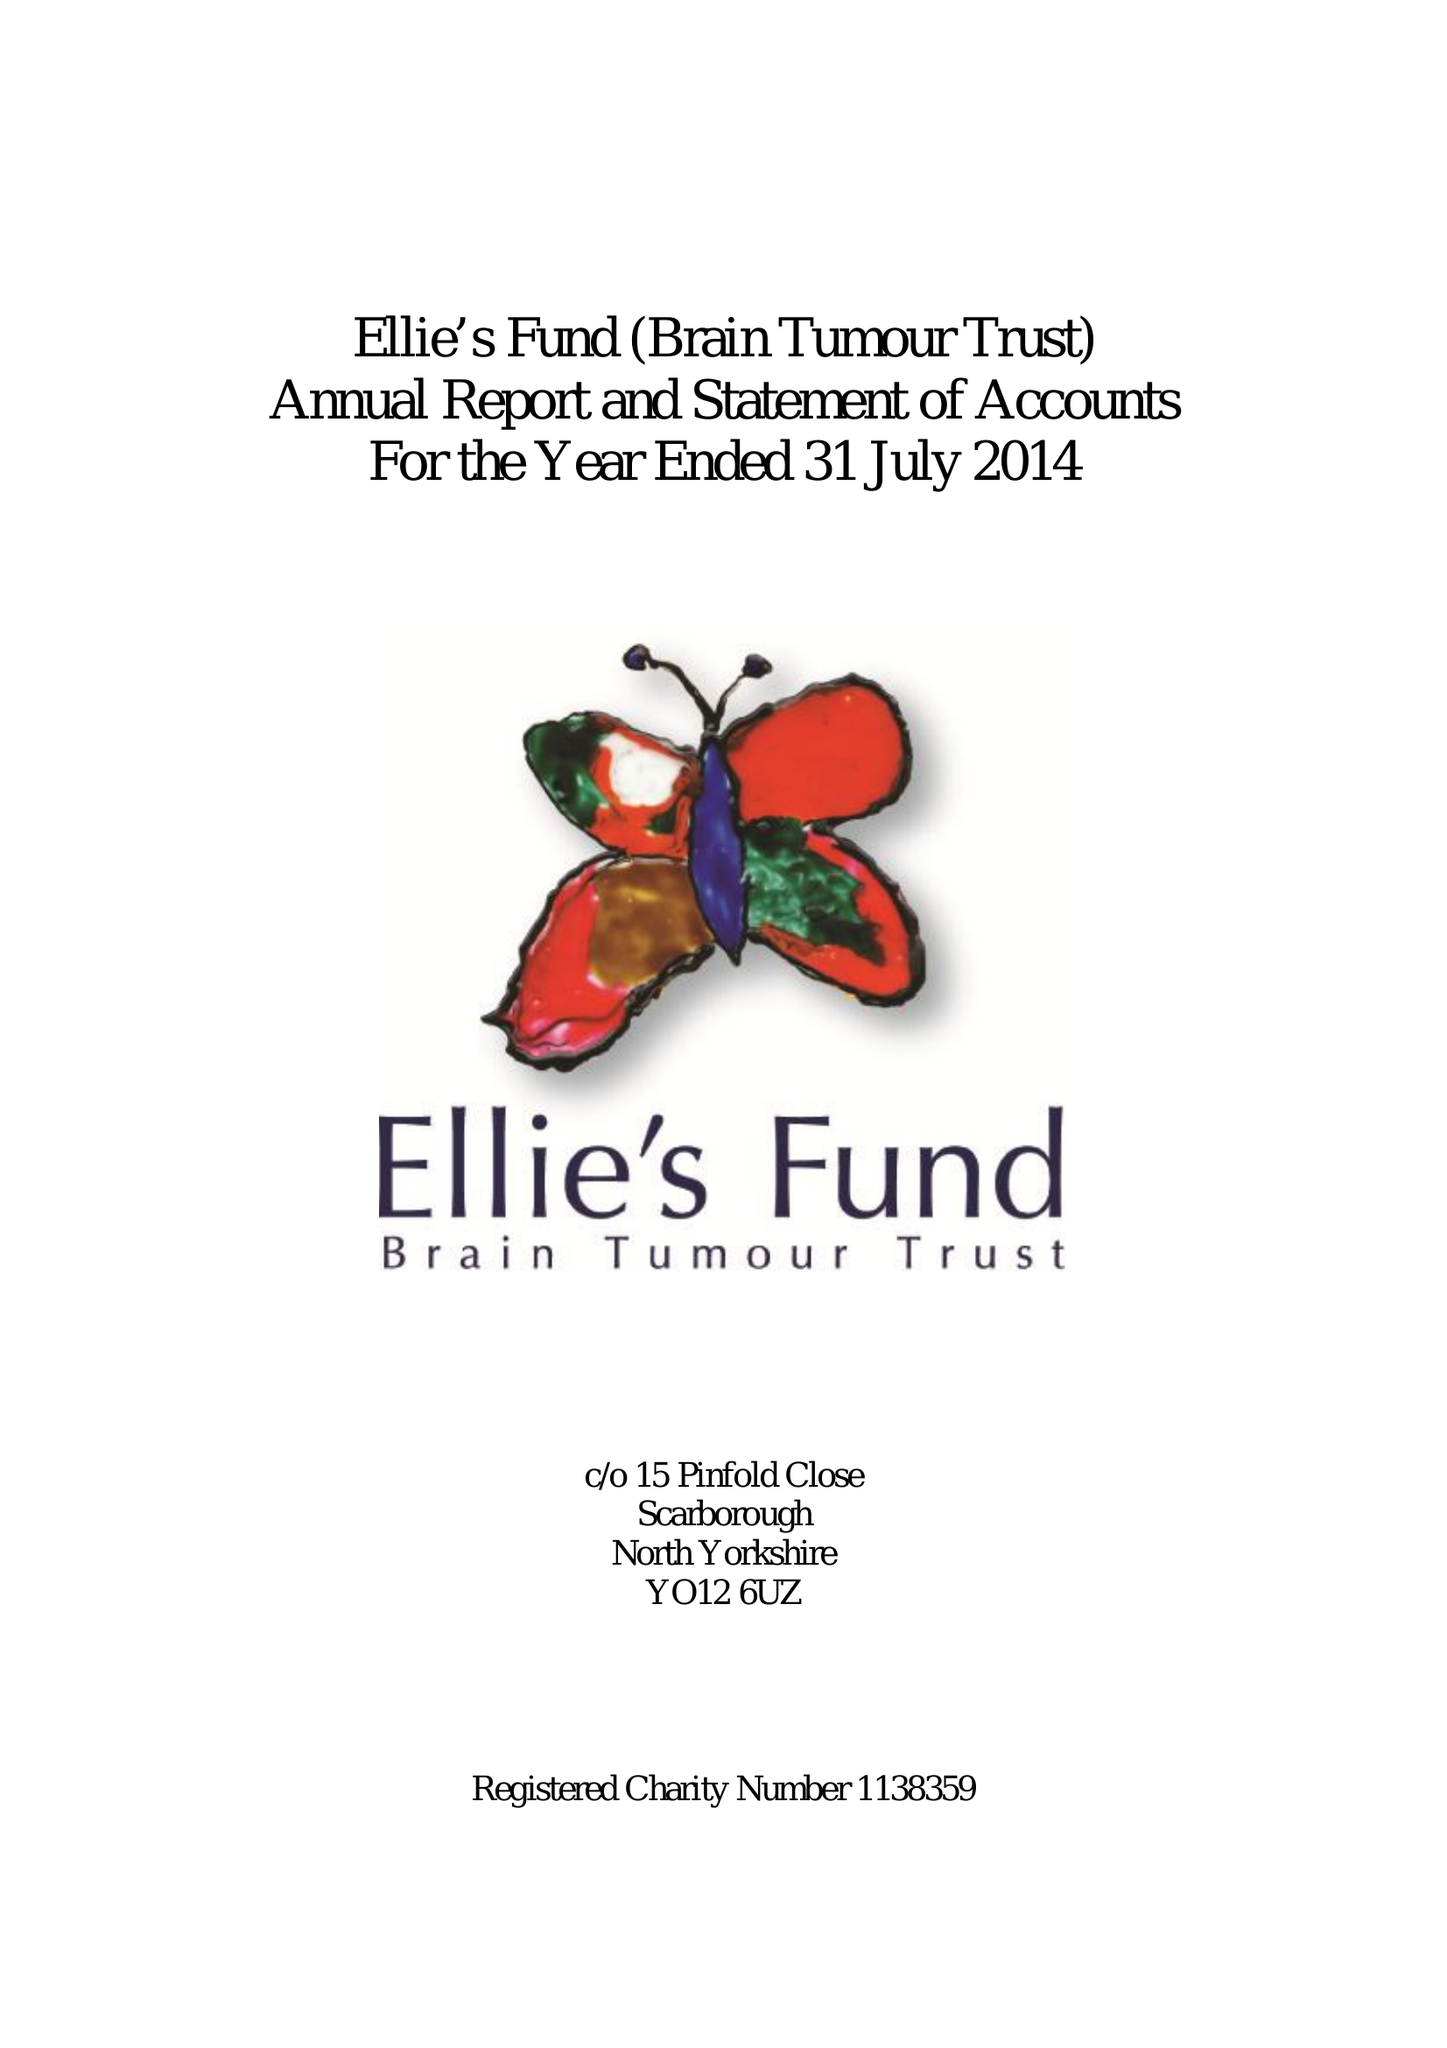What is the value for the spending_annually_in_british_pounds?
Answer the question using a single word or phrase. 20987.00 